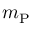<formula> <loc_0><loc_0><loc_500><loc_500>m _ { P }</formula> 